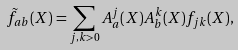<formula> <loc_0><loc_0><loc_500><loc_500>\tilde { f } _ { a b } ( X ) = \sum _ { j , k > 0 } A _ { a } ^ { j } ( X ) A _ { b } ^ { k } ( X ) f _ { j k } ( X ) ,</formula> 